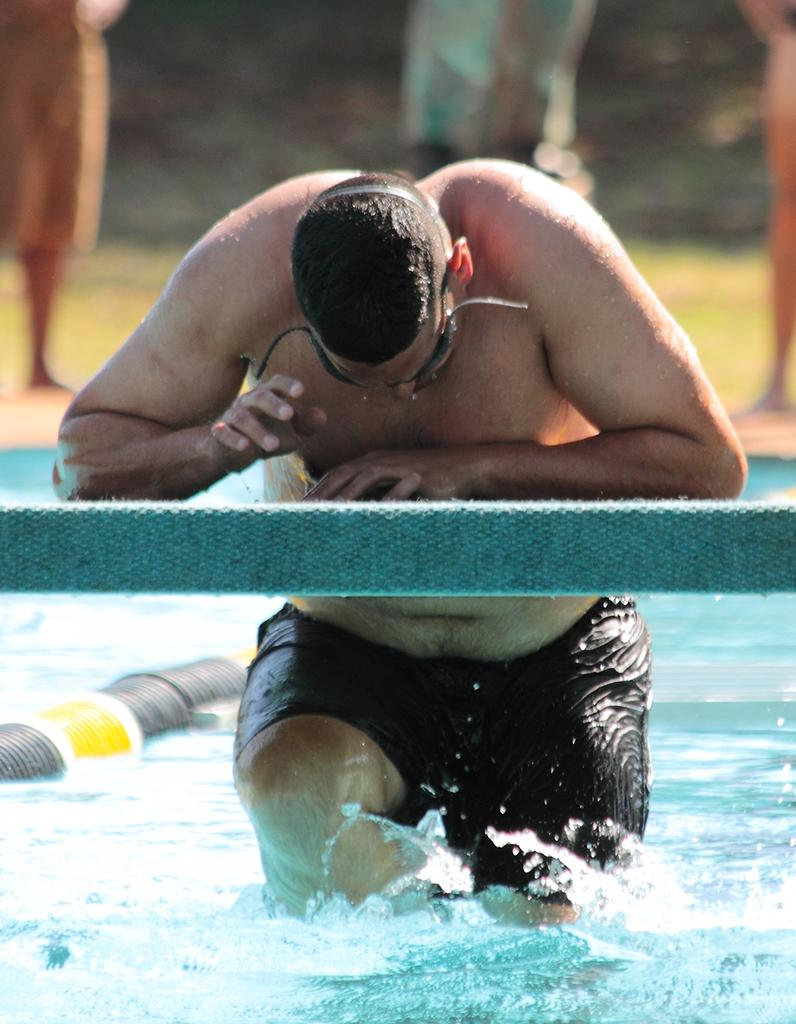What is the man in the image doing? The man is standing in the swimming pool. What is the man touching while standing in the pool? The man has his hand on a desk. Can you describe the people in the background of the image? The people in the background are standing on the ground. What type of game are the people in the background playing in the image? There is no game being played by the people in the background; they are simply standing on the ground. 